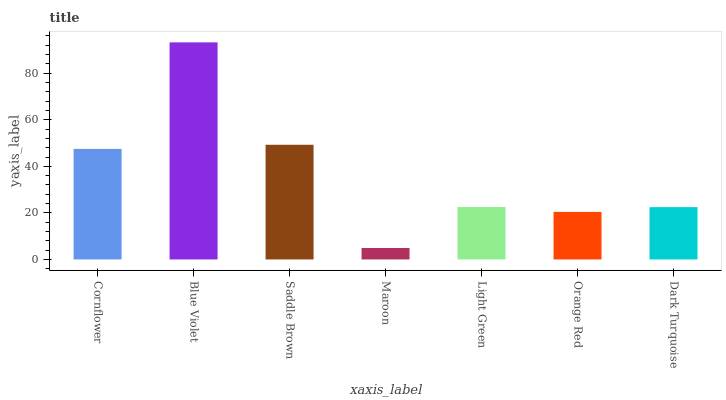Is Maroon the minimum?
Answer yes or no. Yes. Is Blue Violet the maximum?
Answer yes or no. Yes. Is Saddle Brown the minimum?
Answer yes or no. No. Is Saddle Brown the maximum?
Answer yes or no. No. Is Blue Violet greater than Saddle Brown?
Answer yes or no. Yes. Is Saddle Brown less than Blue Violet?
Answer yes or no. Yes. Is Saddle Brown greater than Blue Violet?
Answer yes or no. No. Is Blue Violet less than Saddle Brown?
Answer yes or no. No. Is Light Green the high median?
Answer yes or no. Yes. Is Light Green the low median?
Answer yes or no. Yes. Is Orange Red the high median?
Answer yes or no. No. Is Dark Turquoise the low median?
Answer yes or no. No. 